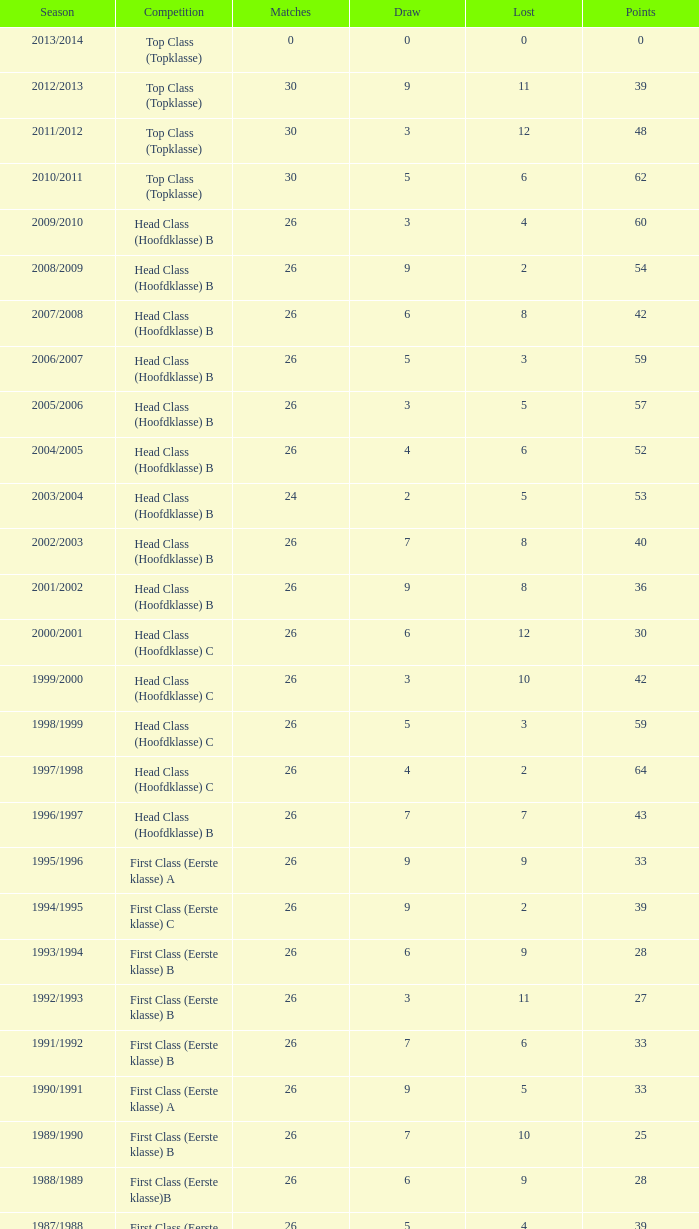What is the sum of the losses that a match score larger than 26, a points score of 62, and a draw greater than 5? None. Give me the full table as a dictionary. {'header': ['Season', 'Competition', 'Matches', 'Draw', 'Lost', 'Points'], 'rows': [['2013/2014', 'Top Class (Topklasse)', '0', '0', '0', '0'], ['2012/2013', 'Top Class (Topklasse)', '30', '9', '11', '39'], ['2011/2012', 'Top Class (Topklasse)', '30', '3', '12', '48'], ['2010/2011', 'Top Class (Topklasse)', '30', '5', '6', '62'], ['2009/2010', 'Head Class (Hoofdklasse) B', '26', '3', '4', '60'], ['2008/2009', 'Head Class (Hoofdklasse) B', '26', '9', '2', '54'], ['2007/2008', 'Head Class (Hoofdklasse) B', '26', '6', '8', '42'], ['2006/2007', 'Head Class (Hoofdklasse) B', '26', '5', '3', '59'], ['2005/2006', 'Head Class (Hoofdklasse) B', '26', '3', '5', '57'], ['2004/2005', 'Head Class (Hoofdklasse) B', '26', '4', '6', '52'], ['2003/2004', 'Head Class (Hoofdklasse) B', '24', '2', '5', '53'], ['2002/2003', 'Head Class (Hoofdklasse) B', '26', '7', '8', '40'], ['2001/2002', 'Head Class (Hoofdklasse) B', '26', '9', '8', '36'], ['2000/2001', 'Head Class (Hoofdklasse) C', '26', '6', '12', '30'], ['1999/2000', 'Head Class (Hoofdklasse) C', '26', '3', '10', '42'], ['1998/1999', 'Head Class (Hoofdklasse) C', '26', '5', '3', '59'], ['1997/1998', 'Head Class (Hoofdklasse) C', '26', '4', '2', '64'], ['1996/1997', 'Head Class (Hoofdklasse) B', '26', '7', '7', '43'], ['1995/1996', 'First Class (Eerste klasse) A', '26', '9', '9', '33'], ['1994/1995', 'First Class (Eerste klasse) C', '26', '9', '2', '39'], ['1993/1994', 'First Class (Eerste klasse) B', '26', '6', '9', '28'], ['1992/1993', 'First Class (Eerste klasse) B', '26', '3', '11', '27'], ['1991/1992', 'First Class (Eerste klasse) B', '26', '7', '6', '33'], ['1990/1991', 'First Class (Eerste klasse) A', '26', '9', '5', '33'], ['1989/1990', 'First Class (Eerste klasse) B', '26', '7', '10', '25'], ['1988/1989', 'First Class (Eerste klasse)B', '26', '6', '9', '28'], ['1987/1988', 'First Class (Eerste klasse) A', '26', '5', '4', '39'], ['1986/1987', 'First Class (Eerste klasse) B', '26', '6', '6', '34'], ['1985/1986', 'First Class (Eerste klasse) B', '26', '7', '3', '39'], ['1984/1985', 'First Class (Eerste klasse) B', '26', '6', '9', '28'], ['1983/1984', 'First Class (Eerste klasse) C', '26', '5', '3', '37'], ['1982/1983', 'First Class (Eerste klasse) B', '26', '10', '1', '40'], ['1981/1982', 'First Class (Eerste klasse) B', '26', '8', '3', '38'], ['1980/1981', 'First Class (Eerste klasse) A', '26', '5', '10', '27'], ['1979/1980', 'First Class (Eerste klasse) B', '26', '6', '9', '28'], ['1978/1979', 'First Class (Eerste klasse) A', '26', '7', '6', '33'], ['1977/1978', 'First Class (Eerste klasse) A', '26', '6', '8', '30'], ['1976/1977', 'First Class (Eerste klasse) B', '26', '7', '3', '39'], ['1975/1976', 'First Class (Eerste klasse)B', '26', '5', '3', '41'], ['1974/1975', 'First Class (Eerste klasse) B', '26', '5', '5', '37'], ['1973/1974', 'First Class (Eerste klasse)A', '22', '6', '4', '30'], ['1972/1973', 'First Class (Eerste klasse) B', '22', '4', '2', '36'], ['1971/1972', 'First Class (Eerste klasse) B', '20', '3', '4', '29'], ['1970/1971', 'First Class (Eerste klasse) A', '18', '6', '4', '24']]} 